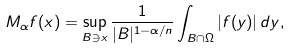<formula> <loc_0><loc_0><loc_500><loc_500>M _ { \alpha } f ( x ) = \sup _ { B \ni x } \frac { 1 } { | B | ^ { 1 - \alpha / n } } \int _ { B \cap \Omega } | f ( y ) | \, d y ,</formula> 